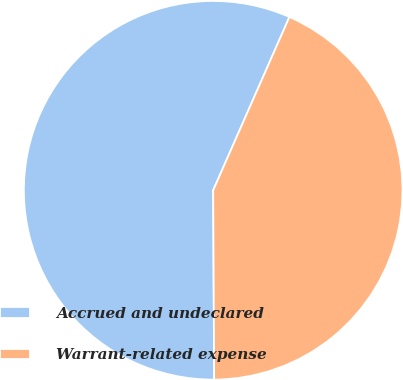Convert chart to OTSL. <chart><loc_0><loc_0><loc_500><loc_500><pie_chart><fcel>Accrued and undeclared<fcel>Warrant-related expense<nl><fcel>56.68%<fcel>43.32%<nl></chart> 